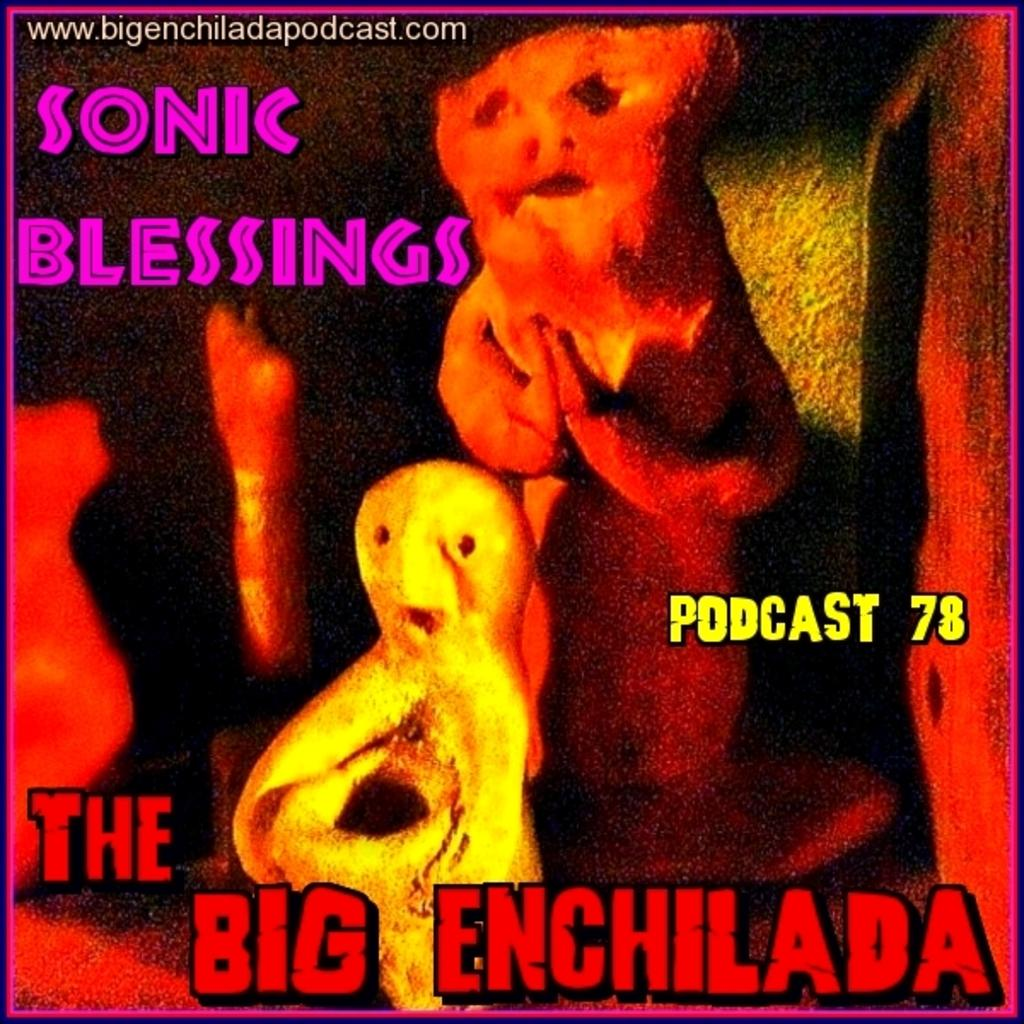<image>
Create a compact narrative representing the image presented. An album is entitled "Sonic Blessings The Big Enchilada". 